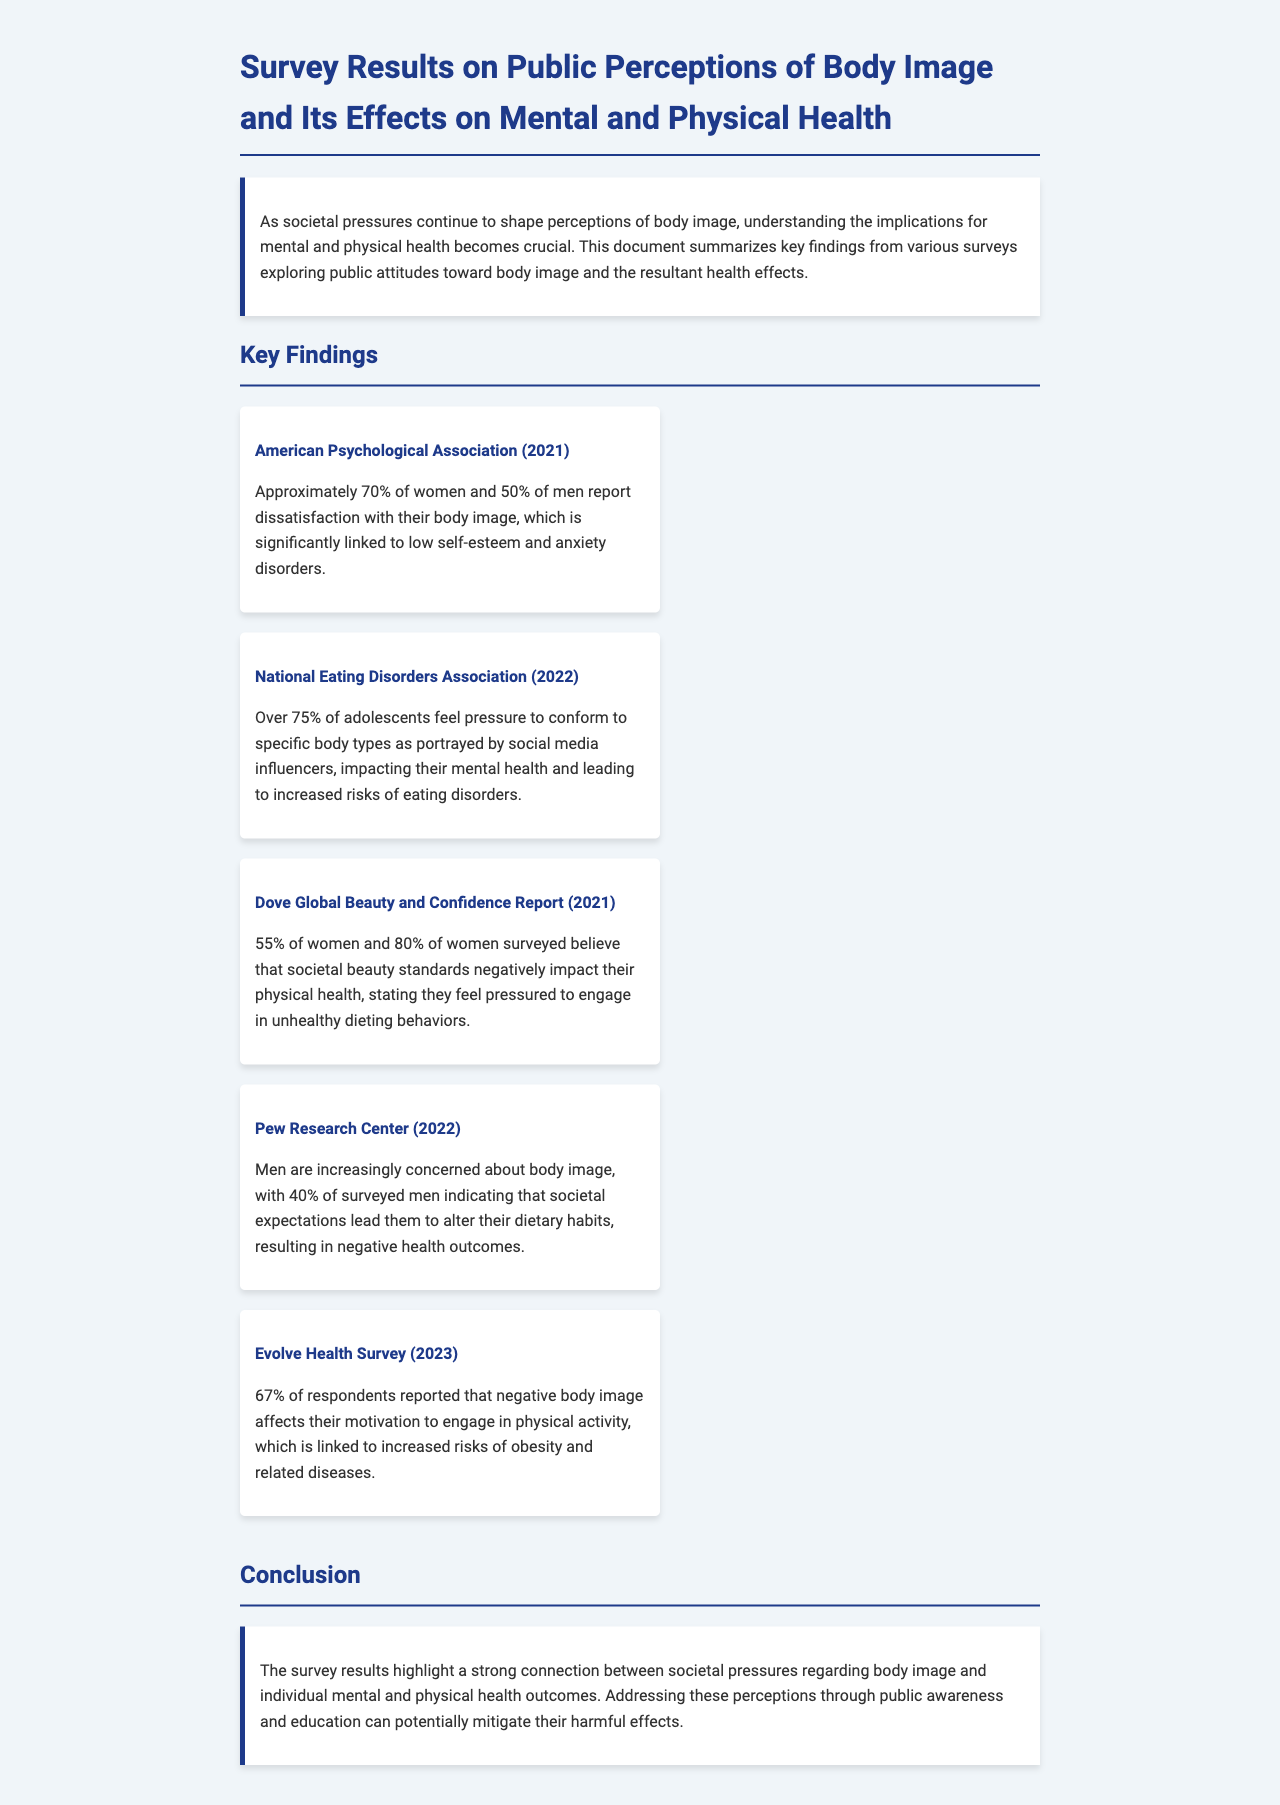what percentage of women report dissatisfaction with their body image? The document states that approximately 70% of women report dissatisfaction with their body image.
Answer: 70% what organization reported over 75% of adolescents feeling pressure to conform to body types? The National Eating Disorders Association conducted a survey highlighting this statistic.
Answer: National Eating Disorders Association what negative impact do societal beauty standards have on women's health according to the Dove report? The Dove report indicates that 80% of women believe societal beauty standards negatively impact their physical health.
Answer: 80% what percentage of men indicated societal expectations alter their dietary habits? According to the Pew Research Center, 40% of surveyed men indicated this concern.
Answer: 40% which report mentions that 67% of respondents are affected in their motivation to engage in physical activity? The Evolve Health Survey contains this finding regarding physical activity motivation.
Answer: Evolve Health Survey how does low self-esteem relate to dissatisfaction with body image according to the American Psychological Association? Approximately 70% of women and 50% of men dissatisfied with body image reported a link to low self-esteem.
Answer: low self-esteem what is a potential solution suggested in the conclusion to mitigate harmful effects of societal pressures? The document suggests addressing these perceptions through public awareness and education.
Answer: public awareness and education 